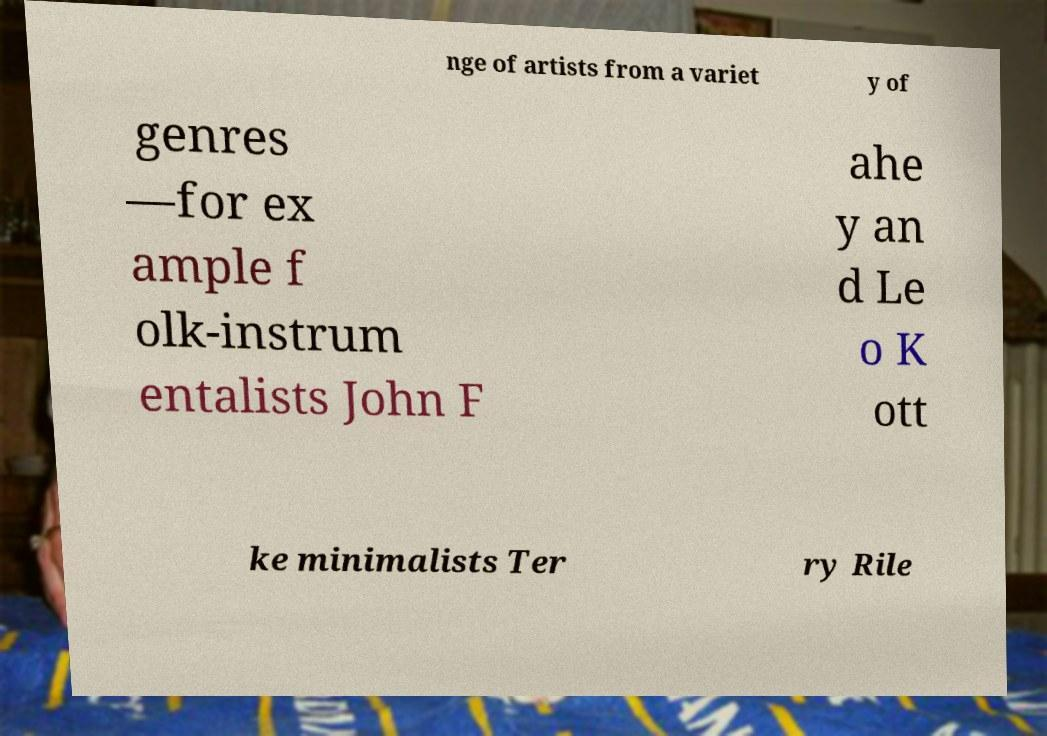What messages or text are displayed in this image? I need them in a readable, typed format. nge of artists from a variet y of genres —for ex ample f olk-instrum entalists John F ahe y an d Le o K ott ke minimalists Ter ry Rile 